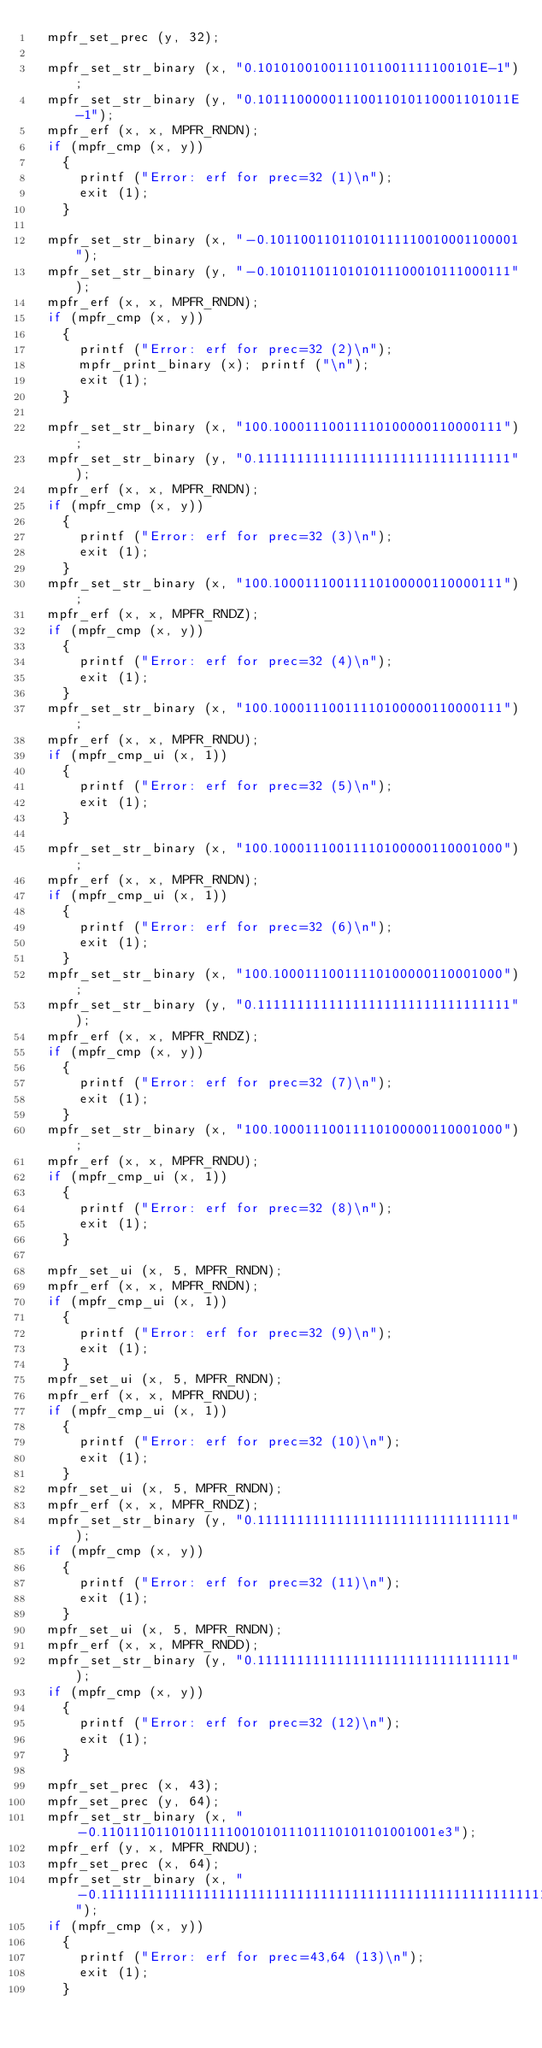Convert code to text. <code><loc_0><loc_0><loc_500><loc_500><_C_>  mpfr_set_prec (y, 32);

  mpfr_set_str_binary (x, "0.1010100100111011001111100101E-1");
  mpfr_set_str_binary (y, "0.10111000001110011010110001101011E-1");
  mpfr_erf (x, x, MPFR_RNDN);
  if (mpfr_cmp (x, y))
    {
      printf ("Error: erf for prec=32 (1)\n");
      exit (1);
    }

  mpfr_set_str_binary (x, "-0.10110011011010111110010001100001");
  mpfr_set_str_binary (y, "-0.1010110110101011100010111000111");
  mpfr_erf (x, x, MPFR_RNDN);
  if (mpfr_cmp (x, y))
    {
      printf ("Error: erf for prec=32 (2)\n");
      mpfr_print_binary (x); printf ("\n");
      exit (1);
    }

  mpfr_set_str_binary (x, "100.10001110011110100000110000111");
  mpfr_set_str_binary (y, "0.11111111111111111111111111111111");
  mpfr_erf (x, x, MPFR_RNDN);
  if (mpfr_cmp (x, y))
    {
      printf ("Error: erf for prec=32 (3)\n");
      exit (1);
    }
  mpfr_set_str_binary (x, "100.10001110011110100000110000111");
  mpfr_erf (x, x, MPFR_RNDZ);
  if (mpfr_cmp (x, y))
    {
      printf ("Error: erf for prec=32 (4)\n");
      exit (1);
    }
  mpfr_set_str_binary (x, "100.10001110011110100000110000111");
  mpfr_erf (x, x, MPFR_RNDU);
  if (mpfr_cmp_ui (x, 1))
    {
      printf ("Error: erf for prec=32 (5)\n");
      exit (1);
    }

  mpfr_set_str_binary (x, "100.10001110011110100000110001000");
  mpfr_erf (x, x, MPFR_RNDN);
  if (mpfr_cmp_ui (x, 1))
    {
      printf ("Error: erf for prec=32 (6)\n");
      exit (1);
    }
  mpfr_set_str_binary (x, "100.10001110011110100000110001000");
  mpfr_set_str_binary (y, "0.11111111111111111111111111111111");
  mpfr_erf (x, x, MPFR_RNDZ);
  if (mpfr_cmp (x, y))
    {
      printf ("Error: erf for prec=32 (7)\n");
      exit (1);
    }
  mpfr_set_str_binary (x, "100.10001110011110100000110001000");
  mpfr_erf (x, x, MPFR_RNDU);
  if (mpfr_cmp_ui (x, 1))
    {
      printf ("Error: erf for prec=32 (8)\n");
      exit (1);
    }

  mpfr_set_ui (x, 5, MPFR_RNDN);
  mpfr_erf (x, x, MPFR_RNDN);
  if (mpfr_cmp_ui (x, 1))
    {
      printf ("Error: erf for prec=32 (9)\n");
      exit (1);
    }
  mpfr_set_ui (x, 5, MPFR_RNDN);
  mpfr_erf (x, x, MPFR_RNDU);
  if (mpfr_cmp_ui (x, 1))
    {
      printf ("Error: erf for prec=32 (10)\n");
      exit (1);
    }
  mpfr_set_ui (x, 5, MPFR_RNDN);
  mpfr_erf (x, x, MPFR_RNDZ);
  mpfr_set_str_binary (y, "0.11111111111111111111111111111111");
  if (mpfr_cmp (x, y))
    {
      printf ("Error: erf for prec=32 (11)\n");
      exit (1);
    }
  mpfr_set_ui (x, 5, MPFR_RNDN);
  mpfr_erf (x, x, MPFR_RNDD);
  mpfr_set_str_binary (y, "0.11111111111111111111111111111111");
  if (mpfr_cmp (x, y))
    {
      printf ("Error: erf for prec=32 (12)\n");
      exit (1);
    }

  mpfr_set_prec (x, 43);
  mpfr_set_prec (y, 64);
  mpfr_set_str_binary (x, "-0.1101110110101111100101011101110101101001001e3");
  mpfr_erf (y, x, MPFR_RNDU);
  mpfr_set_prec (x, 64);
  mpfr_set_str_binary (x, "-0.1111111111111111111111111111111111111111111111111111111111111111");
  if (mpfr_cmp (x, y))
    {
      printf ("Error: erf for prec=43,64 (13)\n");
      exit (1);
    }
</code> 